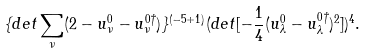Convert formula to latex. <formula><loc_0><loc_0><loc_500><loc_500>\{ d e t \sum _ { \nu } ( 2 - u _ { \nu } ^ { 0 } - u _ { \nu } ^ { 0 \dagger } ) \} ^ { ( - 5 + 1 ) } ( d e t [ - \frac { 1 } { 4 } ( u _ { \lambda } ^ { 0 } - u _ { \lambda } ^ { 0 \dagger } ) ^ { 2 } ] ) ^ { 4 } .</formula> 